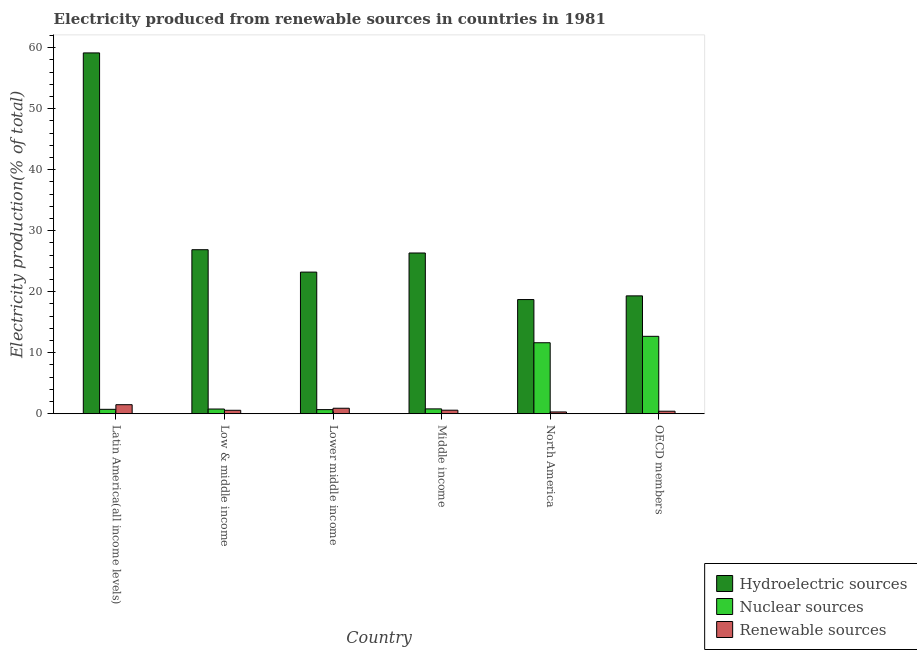How many groups of bars are there?
Give a very brief answer. 6. Are the number of bars per tick equal to the number of legend labels?
Make the answer very short. Yes. Are the number of bars on each tick of the X-axis equal?
Your answer should be very brief. Yes. How many bars are there on the 1st tick from the left?
Your answer should be very brief. 3. How many bars are there on the 5th tick from the right?
Keep it short and to the point. 3. What is the percentage of electricity produced by hydroelectric sources in Lower middle income?
Make the answer very short. 23.21. Across all countries, what is the maximum percentage of electricity produced by renewable sources?
Provide a succinct answer. 1.48. Across all countries, what is the minimum percentage of electricity produced by nuclear sources?
Make the answer very short. 0.67. In which country was the percentage of electricity produced by hydroelectric sources maximum?
Offer a terse response. Latin America(all income levels). In which country was the percentage of electricity produced by hydroelectric sources minimum?
Provide a short and direct response. North America. What is the total percentage of electricity produced by renewable sources in the graph?
Your response must be concise. 4.24. What is the difference between the percentage of electricity produced by hydroelectric sources in Latin America(all income levels) and that in Lower middle income?
Give a very brief answer. 35.92. What is the difference between the percentage of electricity produced by hydroelectric sources in Low & middle income and the percentage of electricity produced by renewable sources in North America?
Your answer should be compact. 26.59. What is the average percentage of electricity produced by renewable sources per country?
Your answer should be compact. 0.71. What is the difference between the percentage of electricity produced by hydroelectric sources and percentage of electricity produced by renewable sources in OECD members?
Offer a terse response. 18.9. What is the ratio of the percentage of electricity produced by nuclear sources in Latin America(all income levels) to that in Middle income?
Ensure brevity in your answer.  0.91. What is the difference between the highest and the second highest percentage of electricity produced by nuclear sources?
Offer a terse response. 1.05. What is the difference between the highest and the lowest percentage of electricity produced by renewable sources?
Give a very brief answer. 1.19. In how many countries, is the percentage of electricity produced by renewable sources greater than the average percentage of electricity produced by renewable sources taken over all countries?
Ensure brevity in your answer.  2. Is the sum of the percentage of electricity produced by hydroelectric sources in Middle income and North America greater than the maximum percentage of electricity produced by renewable sources across all countries?
Offer a terse response. Yes. What does the 2nd bar from the left in OECD members represents?
Provide a succinct answer. Nuclear sources. What does the 3rd bar from the right in OECD members represents?
Your answer should be very brief. Hydroelectric sources. How many bars are there?
Ensure brevity in your answer.  18. How many countries are there in the graph?
Offer a very short reply. 6. Does the graph contain grids?
Your answer should be very brief. No. How are the legend labels stacked?
Provide a succinct answer. Vertical. What is the title of the graph?
Your answer should be very brief. Electricity produced from renewable sources in countries in 1981. Does "Industry" appear as one of the legend labels in the graph?
Provide a short and direct response. No. What is the label or title of the X-axis?
Offer a terse response. Country. What is the label or title of the Y-axis?
Your answer should be very brief. Electricity production(% of total). What is the Electricity production(% of total) in Hydroelectric sources in Latin America(all income levels)?
Give a very brief answer. 59.13. What is the Electricity production(% of total) of Nuclear sources in Latin America(all income levels)?
Give a very brief answer. 0.73. What is the Electricity production(% of total) of Renewable sources in Latin America(all income levels)?
Give a very brief answer. 1.48. What is the Electricity production(% of total) of Hydroelectric sources in Low & middle income?
Make the answer very short. 26.88. What is the Electricity production(% of total) of Nuclear sources in Low & middle income?
Ensure brevity in your answer.  0.77. What is the Electricity production(% of total) in Renewable sources in Low & middle income?
Offer a very short reply. 0.57. What is the Electricity production(% of total) of Hydroelectric sources in Lower middle income?
Give a very brief answer. 23.21. What is the Electricity production(% of total) of Nuclear sources in Lower middle income?
Your answer should be compact. 0.67. What is the Electricity production(% of total) in Renewable sources in Lower middle income?
Make the answer very short. 0.9. What is the Electricity production(% of total) of Hydroelectric sources in Middle income?
Make the answer very short. 26.34. What is the Electricity production(% of total) in Nuclear sources in Middle income?
Your response must be concise. 0.8. What is the Electricity production(% of total) of Renewable sources in Middle income?
Provide a short and direct response. 0.58. What is the Electricity production(% of total) of Hydroelectric sources in North America?
Offer a terse response. 18.71. What is the Electricity production(% of total) in Nuclear sources in North America?
Make the answer very short. 11.63. What is the Electricity production(% of total) of Renewable sources in North America?
Your response must be concise. 0.29. What is the Electricity production(% of total) of Hydroelectric sources in OECD members?
Your answer should be very brief. 19.32. What is the Electricity production(% of total) in Nuclear sources in OECD members?
Keep it short and to the point. 12.69. What is the Electricity production(% of total) of Renewable sources in OECD members?
Offer a very short reply. 0.41. Across all countries, what is the maximum Electricity production(% of total) of Hydroelectric sources?
Provide a succinct answer. 59.13. Across all countries, what is the maximum Electricity production(% of total) of Nuclear sources?
Keep it short and to the point. 12.69. Across all countries, what is the maximum Electricity production(% of total) of Renewable sources?
Offer a terse response. 1.48. Across all countries, what is the minimum Electricity production(% of total) of Hydroelectric sources?
Keep it short and to the point. 18.71. Across all countries, what is the minimum Electricity production(% of total) of Nuclear sources?
Your answer should be compact. 0.67. Across all countries, what is the minimum Electricity production(% of total) in Renewable sources?
Your response must be concise. 0.29. What is the total Electricity production(% of total) of Hydroelectric sources in the graph?
Your response must be concise. 173.59. What is the total Electricity production(% of total) of Nuclear sources in the graph?
Offer a very short reply. 27.29. What is the total Electricity production(% of total) of Renewable sources in the graph?
Your answer should be compact. 4.24. What is the difference between the Electricity production(% of total) in Hydroelectric sources in Latin America(all income levels) and that in Low & middle income?
Your answer should be compact. 32.25. What is the difference between the Electricity production(% of total) in Nuclear sources in Latin America(all income levels) and that in Low & middle income?
Offer a terse response. -0.05. What is the difference between the Electricity production(% of total) of Renewable sources in Latin America(all income levels) and that in Low & middle income?
Ensure brevity in your answer.  0.92. What is the difference between the Electricity production(% of total) of Hydroelectric sources in Latin America(all income levels) and that in Lower middle income?
Keep it short and to the point. 35.92. What is the difference between the Electricity production(% of total) in Nuclear sources in Latin America(all income levels) and that in Lower middle income?
Provide a succinct answer. 0.05. What is the difference between the Electricity production(% of total) in Renewable sources in Latin America(all income levels) and that in Lower middle income?
Ensure brevity in your answer.  0.58. What is the difference between the Electricity production(% of total) in Hydroelectric sources in Latin America(all income levels) and that in Middle income?
Offer a very short reply. 32.79. What is the difference between the Electricity production(% of total) of Nuclear sources in Latin America(all income levels) and that in Middle income?
Make the answer very short. -0.07. What is the difference between the Electricity production(% of total) in Renewable sources in Latin America(all income levels) and that in Middle income?
Provide a short and direct response. 0.9. What is the difference between the Electricity production(% of total) in Hydroelectric sources in Latin America(all income levels) and that in North America?
Your answer should be compact. 40.42. What is the difference between the Electricity production(% of total) in Nuclear sources in Latin America(all income levels) and that in North America?
Provide a succinct answer. -10.91. What is the difference between the Electricity production(% of total) in Renewable sources in Latin America(all income levels) and that in North America?
Your answer should be very brief. 1.19. What is the difference between the Electricity production(% of total) in Hydroelectric sources in Latin America(all income levels) and that in OECD members?
Your response must be concise. 39.81. What is the difference between the Electricity production(% of total) in Nuclear sources in Latin America(all income levels) and that in OECD members?
Your answer should be very brief. -11.96. What is the difference between the Electricity production(% of total) in Renewable sources in Latin America(all income levels) and that in OECD members?
Your answer should be very brief. 1.07. What is the difference between the Electricity production(% of total) of Hydroelectric sources in Low & middle income and that in Lower middle income?
Your answer should be very brief. 3.67. What is the difference between the Electricity production(% of total) in Nuclear sources in Low & middle income and that in Lower middle income?
Provide a succinct answer. 0.1. What is the difference between the Electricity production(% of total) of Renewable sources in Low & middle income and that in Lower middle income?
Keep it short and to the point. -0.34. What is the difference between the Electricity production(% of total) of Hydroelectric sources in Low & middle income and that in Middle income?
Give a very brief answer. 0.54. What is the difference between the Electricity production(% of total) of Nuclear sources in Low & middle income and that in Middle income?
Make the answer very short. -0.02. What is the difference between the Electricity production(% of total) of Renewable sources in Low & middle income and that in Middle income?
Provide a succinct answer. -0.02. What is the difference between the Electricity production(% of total) in Hydroelectric sources in Low & middle income and that in North America?
Make the answer very short. 8.17. What is the difference between the Electricity production(% of total) in Nuclear sources in Low & middle income and that in North America?
Your answer should be very brief. -10.86. What is the difference between the Electricity production(% of total) of Renewable sources in Low & middle income and that in North America?
Offer a terse response. 0.27. What is the difference between the Electricity production(% of total) of Hydroelectric sources in Low & middle income and that in OECD members?
Offer a terse response. 7.56. What is the difference between the Electricity production(% of total) of Nuclear sources in Low & middle income and that in OECD members?
Provide a short and direct response. -11.91. What is the difference between the Electricity production(% of total) of Renewable sources in Low & middle income and that in OECD members?
Make the answer very short. 0.15. What is the difference between the Electricity production(% of total) of Hydroelectric sources in Lower middle income and that in Middle income?
Your response must be concise. -3.13. What is the difference between the Electricity production(% of total) of Nuclear sources in Lower middle income and that in Middle income?
Offer a terse response. -0.12. What is the difference between the Electricity production(% of total) in Renewable sources in Lower middle income and that in Middle income?
Offer a very short reply. 0.32. What is the difference between the Electricity production(% of total) of Hydroelectric sources in Lower middle income and that in North America?
Offer a terse response. 4.5. What is the difference between the Electricity production(% of total) of Nuclear sources in Lower middle income and that in North America?
Your answer should be compact. -10.96. What is the difference between the Electricity production(% of total) of Renewable sources in Lower middle income and that in North America?
Your response must be concise. 0.61. What is the difference between the Electricity production(% of total) in Hydroelectric sources in Lower middle income and that in OECD members?
Offer a very short reply. 3.9. What is the difference between the Electricity production(% of total) in Nuclear sources in Lower middle income and that in OECD members?
Keep it short and to the point. -12.01. What is the difference between the Electricity production(% of total) in Renewable sources in Lower middle income and that in OECD members?
Keep it short and to the point. 0.49. What is the difference between the Electricity production(% of total) of Hydroelectric sources in Middle income and that in North America?
Make the answer very short. 7.63. What is the difference between the Electricity production(% of total) in Nuclear sources in Middle income and that in North America?
Your response must be concise. -10.84. What is the difference between the Electricity production(% of total) of Renewable sources in Middle income and that in North America?
Keep it short and to the point. 0.29. What is the difference between the Electricity production(% of total) of Hydroelectric sources in Middle income and that in OECD members?
Your answer should be compact. 7.03. What is the difference between the Electricity production(% of total) of Nuclear sources in Middle income and that in OECD members?
Provide a short and direct response. -11.89. What is the difference between the Electricity production(% of total) in Renewable sources in Middle income and that in OECD members?
Ensure brevity in your answer.  0.17. What is the difference between the Electricity production(% of total) in Hydroelectric sources in North America and that in OECD members?
Your response must be concise. -0.6. What is the difference between the Electricity production(% of total) in Nuclear sources in North America and that in OECD members?
Make the answer very short. -1.05. What is the difference between the Electricity production(% of total) in Renewable sources in North America and that in OECD members?
Ensure brevity in your answer.  -0.12. What is the difference between the Electricity production(% of total) in Hydroelectric sources in Latin America(all income levels) and the Electricity production(% of total) in Nuclear sources in Low & middle income?
Your answer should be compact. 58.36. What is the difference between the Electricity production(% of total) in Hydroelectric sources in Latin America(all income levels) and the Electricity production(% of total) in Renewable sources in Low & middle income?
Provide a short and direct response. 58.56. What is the difference between the Electricity production(% of total) of Nuclear sources in Latin America(all income levels) and the Electricity production(% of total) of Renewable sources in Low & middle income?
Give a very brief answer. 0.16. What is the difference between the Electricity production(% of total) in Hydroelectric sources in Latin America(all income levels) and the Electricity production(% of total) in Nuclear sources in Lower middle income?
Provide a short and direct response. 58.45. What is the difference between the Electricity production(% of total) in Hydroelectric sources in Latin America(all income levels) and the Electricity production(% of total) in Renewable sources in Lower middle income?
Ensure brevity in your answer.  58.23. What is the difference between the Electricity production(% of total) in Nuclear sources in Latin America(all income levels) and the Electricity production(% of total) in Renewable sources in Lower middle income?
Make the answer very short. -0.18. What is the difference between the Electricity production(% of total) of Hydroelectric sources in Latin America(all income levels) and the Electricity production(% of total) of Nuclear sources in Middle income?
Provide a succinct answer. 58.33. What is the difference between the Electricity production(% of total) in Hydroelectric sources in Latin America(all income levels) and the Electricity production(% of total) in Renewable sources in Middle income?
Give a very brief answer. 58.55. What is the difference between the Electricity production(% of total) of Nuclear sources in Latin America(all income levels) and the Electricity production(% of total) of Renewable sources in Middle income?
Your answer should be very brief. 0.14. What is the difference between the Electricity production(% of total) of Hydroelectric sources in Latin America(all income levels) and the Electricity production(% of total) of Nuclear sources in North America?
Provide a succinct answer. 47.49. What is the difference between the Electricity production(% of total) of Hydroelectric sources in Latin America(all income levels) and the Electricity production(% of total) of Renewable sources in North America?
Make the answer very short. 58.84. What is the difference between the Electricity production(% of total) of Nuclear sources in Latin America(all income levels) and the Electricity production(% of total) of Renewable sources in North America?
Your answer should be compact. 0.43. What is the difference between the Electricity production(% of total) in Hydroelectric sources in Latin America(all income levels) and the Electricity production(% of total) in Nuclear sources in OECD members?
Give a very brief answer. 46.44. What is the difference between the Electricity production(% of total) in Hydroelectric sources in Latin America(all income levels) and the Electricity production(% of total) in Renewable sources in OECD members?
Provide a succinct answer. 58.72. What is the difference between the Electricity production(% of total) in Nuclear sources in Latin America(all income levels) and the Electricity production(% of total) in Renewable sources in OECD members?
Your answer should be compact. 0.31. What is the difference between the Electricity production(% of total) of Hydroelectric sources in Low & middle income and the Electricity production(% of total) of Nuclear sources in Lower middle income?
Your response must be concise. 26.2. What is the difference between the Electricity production(% of total) in Hydroelectric sources in Low & middle income and the Electricity production(% of total) in Renewable sources in Lower middle income?
Your answer should be very brief. 25.98. What is the difference between the Electricity production(% of total) in Nuclear sources in Low & middle income and the Electricity production(% of total) in Renewable sources in Lower middle income?
Ensure brevity in your answer.  -0.13. What is the difference between the Electricity production(% of total) in Hydroelectric sources in Low & middle income and the Electricity production(% of total) in Nuclear sources in Middle income?
Your answer should be compact. 26.08. What is the difference between the Electricity production(% of total) in Hydroelectric sources in Low & middle income and the Electricity production(% of total) in Renewable sources in Middle income?
Your answer should be very brief. 26.3. What is the difference between the Electricity production(% of total) of Nuclear sources in Low & middle income and the Electricity production(% of total) of Renewable sources in Middle income?
Give a very brief answer. 0.19. What is the difference between the Electricity production(% of total) of Hydroelectric sources in Low & middle income and the Electricity production(% of total) of Nuclear sources in North America?
Provide a succinct answer. 15.25. What is the difference between the Electricity production(% of total) of Hydroelectric sources in Low & middle income and the Electricity production(% of total) of Renewable sources in North America?
Offer a terse response. 26.59. What is the difference between the Electricity production(% of total) in Nuclear sources in Low & middle income and the Electricity production(% of total) in Renewable sources in North America?
Your response must be concise. 0.48. What is the difference between the Electricity production(% of total) of Hydroelectric sources in Low & middle income and the Electricity production(% of total) of Nuclear sources in OECD members?
Your answer should be very brief. 14.19. What is the difference between the Electricity production(% of total) in Hydroelectric sources in Low & middle income and the Electricity production(% of total) in Renewable sources in OECD members?
Provide a short and direct response. 26.47. What is the difference between the Electricity production(% of total) in Nuclear sources in Low & middle income and the Electricity production(% of total) in Renewable sources in OECD members?
Give a very brief answer. 0.36. What is the difference between the Electricity production(% of total) in Hydroelectric sources in Lower middle income and the Electricity production(% of total) in Nuclear sources in Middle income?
Your response must be concise. 22.41. What is the difference between the Electricity production(% of total) of Hydroelectric sources in Lower middle income and the Electricity production(% of total) of Renewable sources in Middle income?
Provide a succinct answer. 22.63. What is the difference between the Electricity production(% of total) of Nuclear sources in Lower middle income and the Electricity production(% of total) of Renewable sources in Middle income?
Provide a short and direct response. 0.09. What is the difference between the Electricity production(% of total) in Hydroelectric sources in Lower middle income and the Electricity production(% of total) in Nuclear sources in North America?
Give a very brief answer. 11.58. What is the difference between the Electricity production(% of total) of Hydroelectric sources in Lower middle income and the Electricity production(% of total) of Renewable sources in North America?
Provide a succinct answer. 22.92. What is the difference between the Electricity production(% of total) of Nuclear sources in Lower middle income and the Electricity production(% of total) of Renewable sources in North America?
Give a very brief answer. 0.38. What is the difference between the Electricity production(% of total) in Hydroelectric sources in Lower middle income and the Electricity production(% of total) in Nuclear sources in OECD members?
Your answer should be compact. 10.52. What is the difference between the Electricity production(% of total) of Hydroelectric sources in Lower middle income and the Electricity production(% of total) of Renewable sources in OECD members?
Offer a terse response. 22.8. What is the difference between the Electricity production(% of total) in Nuclear sources in Lower middle income and the Electricity production(% of total) in Renewable sources in OECD members?
Give a very brief answer. 0.26. What is the difference between the Electricity production(% of total) in Hydroelectric sources in Middle income and the Electricity production(% of total) in Nuclear sources in North America?
Make the answer very short. 14.71. What is the difference between the Electricity production(% of total) in Hydroelectric sources in Middle income and the Electricity production(% of total) in Renewable sources in North America?
Make the answer very short. 26.05. What is the difference between the Electricity production(% of total) of Nuclear sources in Middle income and the Electricity production(% of total) of Renewable sources in North America?
Keep it short and to the point. 0.5. What is the difference between the Electricity production(% of total) of Hydroelectric sources in Middle income and the Electricity production(% of total) of Nuclear sources in OECD members?
Your response must be concise. 13.66. What is the difference between the Electricity production(% of total) of Hydroelectric sources in Middle income and the Electricity production(% of total) of Renewable sources in OECD members?
Offer a terse response. 25.93. What is the difference between the Electricity production(% of total) of Nuclear sources in Middle income and the Electricity production(% of total) of Renewable sources in OECD members?
Ensure brevity in your answer.  0.38. What is the difference between the Electricity production(% of total) in Hydroelectric sources in North America and the Electricity production(% of total) in Nuclear sources in OECD members?
Your answer should be compact. 6.03. What is the difference between the Electricity production(% of total) of Hydroelectric sources in North America and the Electricity production(% of total) of Renewable sources in OECD members?
Keep it short and to the point. 18.3. What is the difference between the Electricity production(% of total) in Nuclear sources in North America and the Electricity production(% of total) in Renewable sources in OECD members?
Provide a succinct answer. 11.22. What is the average Electricity production(% of total) of Hydroelectric sources per country?
Give a very brief answer. 28.93. What is the average Electricity production(% of total) of Nuclear sources per country?
Ensure brevity in your answer.  4.55. What is the average Electricity production(% of total) in Renewable sources per country?
Offer a terse response. 0.71. What is the difference between the Electricity production(% of total) in Hydroelectric sources and Electricity production(% of total) in Nuclear sources in Latin America(all income levels)?
Your answer should be very brief. 58.4. What is the difference between the Electricity production(% of total) of Hydroelectric sources and Electricity production(% of total) of Renewable sources in Latin America(all income levels)?
Give a very brief answer. 57.65. What is the difference between the Electricity production(% of total) in Nuclear sources and Electricity production(% of total) in Renewable sources in Latin America(all income levels)?
Your response must be concise. -0.76. What is the difference between the Electricity production(% of total) in Hydroelectric sources and Electricity production(% of total) in Nuclear sources in Low & middle income?
Your answer should be very brief. 26.11. What is the difference between the Electricity production(% of total) of Hydroelectric sources and Electricity production(% of total) of Renewable sources in Low & middle income?
Make the answer very short. 26.31. What is the difference between the Electricity production(% of total) in Nuclear sources and Electricity production(% of total) in Renewable sources in Low & middle income?
Provide a succinct answer. 0.21. What is the difference between the Electricity production(% of total) in Hydroelectric sources and Electricity production(% of total) in Nuclear sources in Lower middle income?
Your answer should be compact. 22.54. What is the difference between the Electricity production(% of total) in Hydroelectric sources and Electricity production(% of total) in Renewable sources in Lower middle income?
Ensure brevity in your answer.  22.31. What is the difference between the Electricity production(% of total) of Nuclear sources and Electricity production(% of total) of Renewable sources in Lower middle income?
Keep it short and to the point. -0.23. What is the difference between the Electricity production(% of total) of Hydroelectric sources and Electricity production(% of total) of Nuclear sources in Middle income?
Your response must be concise. 25.55. What is the difference between the Electricity production(% of total) of Hydroelectric sources and Electricity production(% of total) of Renewable sources in Middle income?
Offer a very short reply. 25.76. What is the difference between the Electricity production(% of total) in Nuclear sources and Electricity production(% of total) in Renewable sources in Middle income?
Ensure brevity in your answer.  0.22. What is the difference between the Electricity production(% of total) in Hydroelectric sources and Electricity production(% of total) in Nuclear sources in North America?
Keep it short and to the point. 7.08. What is the difference between the Electricity production(% of total) in Hydroelectric sources and Electricity production(% of total) in Renewable sources in North America?
Your answer should be compact. 18.42. What is the difference between the Electricity production(% of total) of Nuclear sources and Electricity production(% of total) of Renewable sources in North America?
Offer a terse response. 11.34. What is the difference between the Electricity production(% of total) of Hydroelectric sources and Electricity production(% of total) of Nuclear sources in OECD members?
Provide a short and direct response. 6.63. What is the difference between the Electricity production(% of total) in Hydroelectric sources and Electricity production(% of total) in Renewable sources in OECD members?
Ensure brevity in your answer.  18.9. What is the difference between the Electricity production(% of total) of Nuclear sources and Electricity production(% of total) of Renewable sources in OECD members?
Offer a very short reply. 12.27. What is the ratio of the Electricity production(% of total) of Hydroelectric sources in Latin America(all income levels) to that in Low & middle income?
Ensure brevity in your answer.  2.2. What is the ratio of the Electricity production(% of total) in Nuclear sources in Latin America(all income levels) to that in Low & middle income?
Make the answer very short. 0.94. What is the ratio of the Electricity production(% of total) in Renewable sources in Latin America(all income levels) to that in Low & middle income?
Your answer should be very brief. 2.62. What is the ratio of the Electricity production(% of total) of Hydroelectric sources in Latin America(all income levels) to that in Lower middle income?
Your response must be concise. 2.55. What is the ratio of the Electricity production(% of total) in Nuclear sources in Latin America(all income levels) to that in Lower middle income?
Your answer should be very brief. 1.07. What is the ratio of the Electricity production(% of total) in Renewable sources in Latin America(all income levels) to that in Lower middle income?
Give a very brief answer. 1.65. What is the ratio of the Electricity production(% of total) of Hydroelectric sources in Latin America(all income levels) to that in Middle income?
Your answer should be compact. 2.24. What is the ratio of the Electricity production(% of total) of Nuclear sources in Latin America(all income levels) to that in Middle income?
Keep it short and to the point. 0.91. What is the ratio of the Electricity production(% of total) of Renewable sources in Latin America(all income levels) to that in Middle income?
Provide a short and direct response. 2.55. What is the ratio of the Electricity production(% of total) of Hydroelectric sources in Latin America(all income levels) to that in North America?
Ensure brevity in your answer.  3.16. What is the ratio of the Electricity production(% of total) in Nuclear sources in Latin America(all income levels) to that in North America?
Make the answer very short. 0.06. What is the ratio of the Electricity production(% of total) in Renewable sources in Latin America(all income levels) to that in North America?
Keep it short and to the point. 5.04. What is the ratio of the Electricity production(% of total) in Hydroelectric sources in Latin America(all income levels) to that in OECD members?
Your answer should be very brief. 3.06. What is the ratio of the Electricity production(% of total) of Nuclear sources in Latin America(all income levels) to that in OECD members?
Keep it short and to the point. 0.06. What is the ratio of the Electricity production(% of total) of Renewable sources in Latin America(all income levels) to that in OECD members?
Offer a terse response. 3.58. What is the ratio of the Electricity production(% of total) in Hydroelectric sources in Low & middle income to that in Lower middle income?
Offer a very short reply. 1.16. What is the ratio of the Electricity production(% of total) in Nuclear sources in Low & middle income to that in Lower middle income?
Provide a succinct answer. 1.15. What is the ratio of the Electricity production(% of total) in Renewable sources in Low & middle income to that in Lower middle income?
Offer a very short reply. 0.63. What is the ratio of the Electricity production(% of total) of Hydroelectric sources in Low & middle income to that in Middle income?
Provide a succinct answer. 1.02. What is the ratio of the Electricity production(% of total) in Nuclear sources in Low & middle income to that in Middle income?
Your response must be concise. 0.97. What is the ratio of the Electricity production(% of total) in Renewable sources in Low & middle income to that in Middle income?
Make the answer very short. 0.97. What is the ratio of the Electricity production(% of total) of Hydroelectric sources in Low & middle income to that in North America?
Provide a short and direct response. 1.44. What is the ratio of the Electricity production(% of total) in Nuclear sources in Low & middle income to that in North America?
Provide a short and direct response. 0.07. What is the ratio of the Electricity production(% of total) of Renewable sources in Low & middle income to that in North America?
Make the answer very short. 1.92. What is the ratio of the Electricity production(% of total) in Hydroelectric sources in Low & middle income to that in OECD members?
Your answer should be compact. 1.39. What is the ratio of the Electricity production(% of total) of Nuclear sources in Low & middle income to that in OECD members?
Ensure brevity in your answer.  0.06. What is the ratio of the Electricity production(% of total) of Renewable sources in Low & middle income to that in OECD members?
Offer a very short reply. 1.37. What is the ratio of the Electricity production(% of total) of Hydroelectric sources in Lower middle income to that in Middle income?
Your answer should be compact. 0.88. What is the ratio of the Electricity production(% of total) of Nuclear sources in Lower middle income to that in Middle income?
Offer a terse response. 0.85. What is the ratio of the Electricity production(% of total) in Renewable sources in Lower middle income to that in Middle income?
Give a very brief answer. 1.55. What is the ratio of the Electricity production(% of total) of Hydroelectric sources in Lower middle income to that in North America?
Ensure brevity in your answer.  1.24. What is the ratio of the Electricity production(% of total) in Nuclear sources in Lower middle income to that in North America?
Make the answer very short. 0.06. What is the ratio of the Electricity production(% of total) of Renewable sources in Lower middle income to that in North America?
Your response must be concise. 3.07. What is the ratio of the Electricity production(% of total) in Hydroelectric sources in Lower middle income to that in OECD members?
Offer a terse response. 1.2. What is the ratio of the Electricity production(% of total) of Nuclear sources in Lower middle income to that in OECD members?
Keep it short and to the point. 0.05. What is the ratio of the Electricity production(% of total) in Renewable sources in Lower middle income to that in OECD members?
Give a very brief answer. 2.18. What is the ratio of the Electricity production(% of total) of Hydroelectric sources in Middle income to that in North America?
Provide a succinct answer. 1.41. What is the ratio of the Electricity production(% of total) of Nuclear sources in Middle income to that in North America?
Keep it short and to the point. 0.07. What is the ratio of the Electricity production(% of total) in Renewable sources in Middle income to that in North America?
Your response must be concise. 1.98. What is the ratio of the Electricity production(% of total) in Hydroelectric sources in Middle income to that in OECD members?
Your answer should be compact. 1.36. What is the ratio of the Electricity production(% of total) of Nuclear sources in Middle income to that in OECD members?
Your response must be concise. 0.06. What is the ratio of the Electricity production(% of total) of Renewable sources in Middle income to that in OECD members?
Give a very brief answer. 1.4. What is the ratio of the Electricity production(% of total) of Hydroelectric sources in North America to that in OECD members?
Keep it short and to the point. 0.97. What is the ratio of the Electricity production(% of total) of Nuclear sources in North America to that in OECD members?
Your response must be concise. 0.92. What is the ratio of the Electricity production(% of total) in Renewable sources in North America to that in OECD members?
Your response must be concise. 0.71. What is the difference between the highest and the second highest Electricity production(% of total) in Hydroelectric sources?
Offer a terse response. 32.25. What is the difference between the highest and the second highest Electricity production(% of total) in Nuclear sources?
Ensure brevity in your answer.  1.05. What is the difference between the highest and the second highest Electricity production(% of total) in Renewable sources?
Keep it short and to the point. 0.58. What is the difference between the highest and the lowest Electricity production(% of total) in Hydroelectric sources?
Keep it short and to the point. 40.42. What is the difference between the highest and the lowest Electricity production(% of total) in Nuclear sources?
Offer a very short reply. 12.01. What is the difference between the highest and the lowest Electricity production(% of total) of Renewable sources?
Provide a short and direct response. 1.19. 